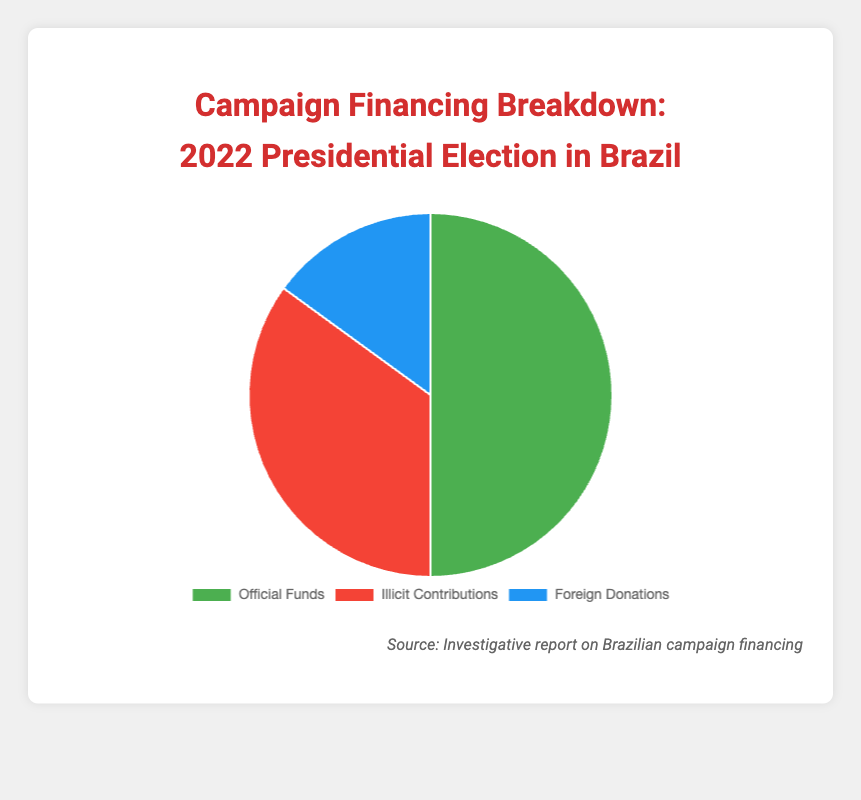What percentage of the campaign financing for the 2022 Presidential Election comes from official funds? The pie chart indicates that official funds account for 50% of the total campaign financing.
Answer: 50% How do the illicit contributions compare between the 2022 Presidential Election and the 2022 Gubernatorial Election in Minas Gerais? The 2022 Presidential Election has 35% in illicit contributions, whereas the 2022 Gubernatorial Election in Minas Gerais has 20%. This means the Presidential Election had a larger share of illicit contributions.
Answer: The Presidential Election had higher illicit contributions (35% vs. 20%) Which category in the 2022 Presidential Election has the smallest percentage? By observing the pie chart, it is clear that foreign donations constitute the smallest percentage, at 15%.
Answer: Foreign Donations What is the combined percentage of illicit contributions and foreign donations for the 2022 Presidential Election? Adding together the percentages for illicit contributions (35%) and foreign donations (15%) gives us a total of 50%.
Answer: 50% Which type of funding receives the most and least representation in the 2022 Presidential Election? The pie chart shows that official funds receive the most representation at 50%, while foreign donations have the least at 15%.
Answer: Most: Official Funds; Least: Foreign Donations Compare the official funds' percentage for the 2022 Presidential Election and the 2016 Mayoral Election in Belo Horizonte. The official funds for the 2022 Presidential Election are at 50%, while for the 2016 Mayoral Election in Belo Horizonte, they are at 70%.
Answer: 2016 Mayoral Election in Belo Horizonte had higher official funds (70% vs. 50%) What can we infer about the reliance on illicit contributions between different election campaigns? By comparing the pie chart data for various campaigns, we see that the 2022 Presidential Election has a higher percentage of illicit contributions (35%) compared to other campaigns such as the 2022 Gubernatorial Election (20%) and the 2016 Mayoral Election in Belo Horizonte (20%). This suggests a higher reliance on illicit contributions in the Presidential Election.
Answer: The 2022 Presidential Election has a higher reliance on illicit contributions How does the share of foreign donations differ across the campaigns listed? The pie chart and provided data indicate that the share of foreign donations is consistent at 15% across most elections except for the 2016 Mayoral Election in Belo Horizonte which has 10%.
Answer: Most elections: 15%, Belo Horizonte Mayoral Election: 10% Which funding type saw the most significant variation in its percentage across different campaigns? Reviewing the data, official funds show the largest variation, ranging from 50% in the 2022 Presidential Election to 70% in the 2016 Mayoral Election in Belo Horizonte.
Answer: Official Funds 